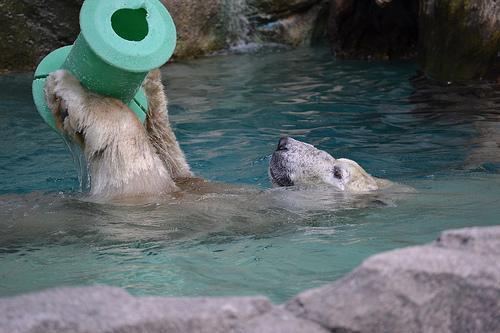How many paws can you see in the photo?
Give a very brief answer. 2. How many eyes can you see in the photo?
Give a very brief answer. 1. 